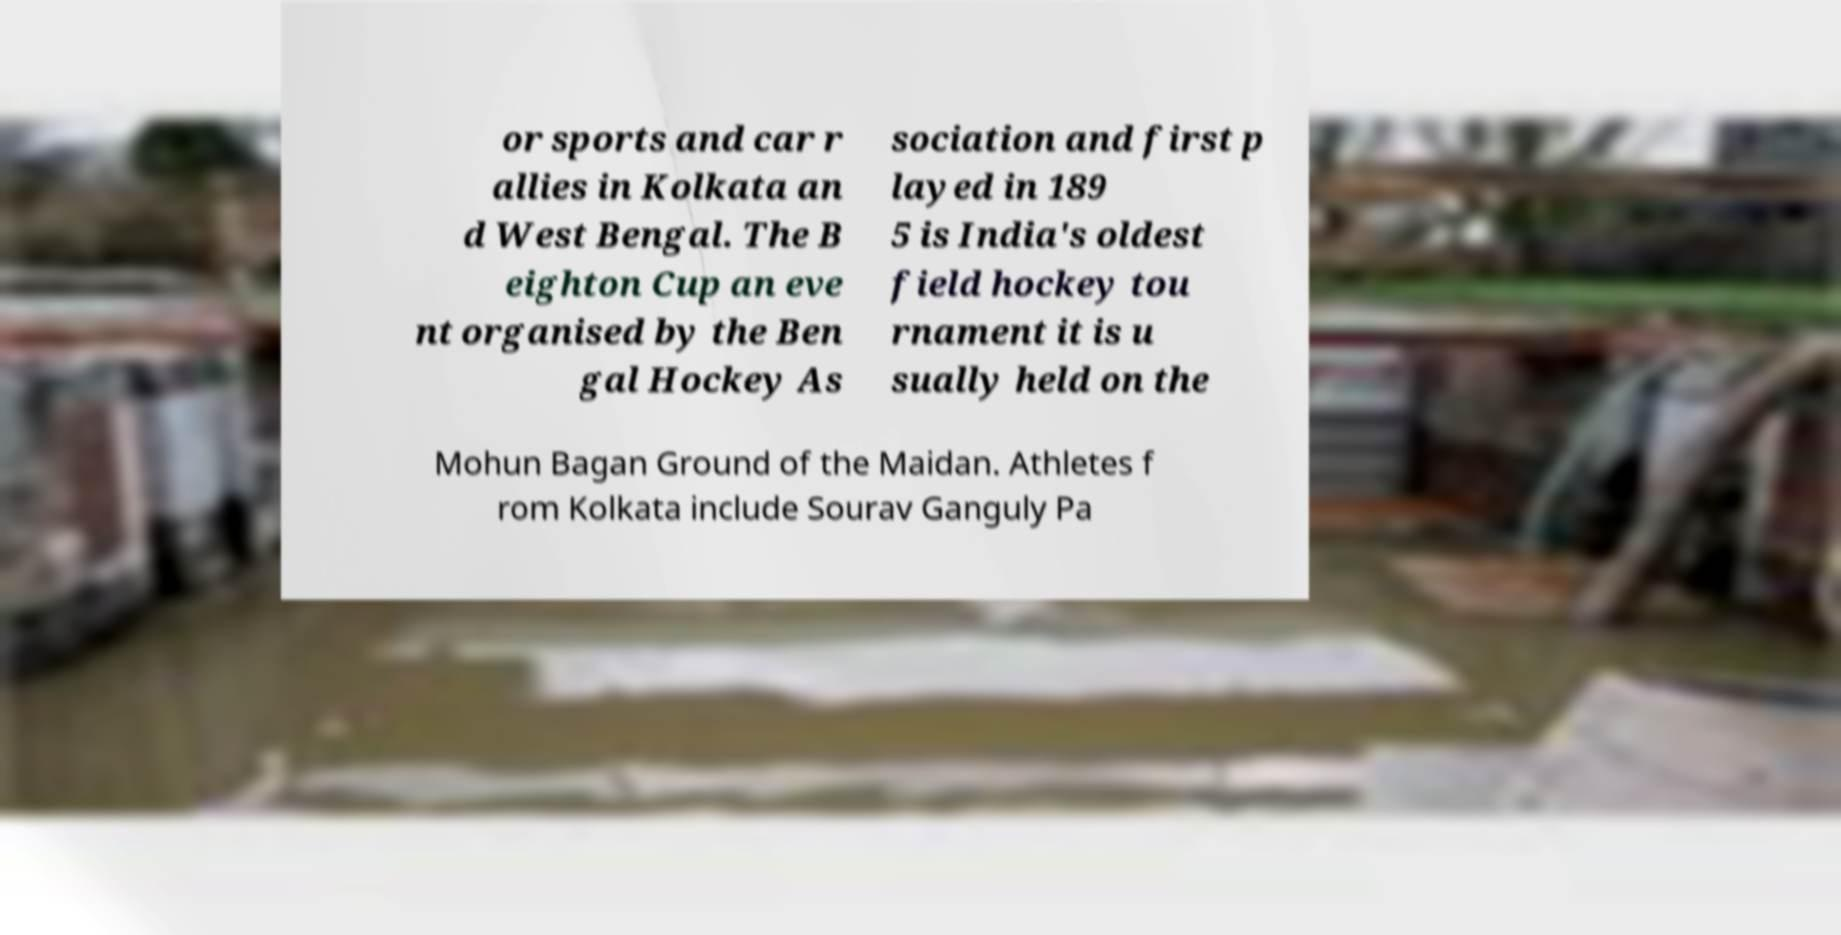What messages or text are displayed in this image? I need them in a readable, typed format. or sports and car r allies in Kolkata an d West Bengal. The B eighton Cup an eve nt organised by the Ben gal Hockey As sociation and first p layed in 189 5 is India's oldest field hockey tou rnament it is u sually held on the Mohun Bagan Ground of the Maidan. Athletes f rom Kolkata include Sourav Ganguly Pa 